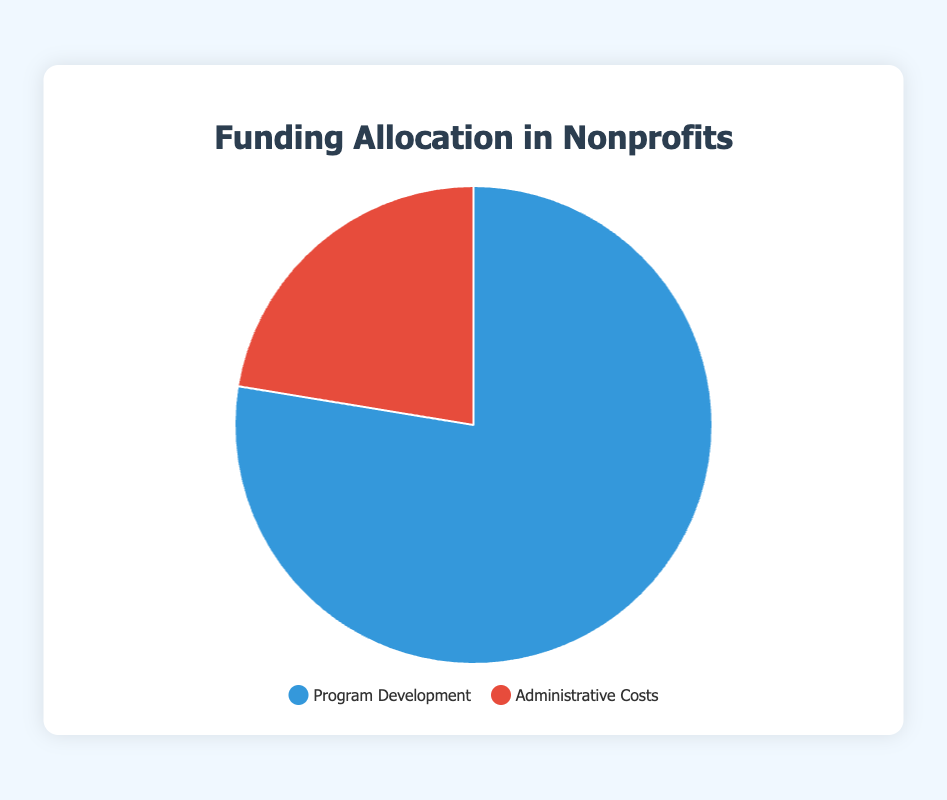What's the average allocation percentage to Program Development among all nonprofits? To calculate the average allocation percentage to Program Development, sum up all the percentages for Program Development and divide by the number of nonprofits. The sum is 75 + 85 + 80 + 70 + 78 = 388. There are 5 nonprofits, so the average is 388/5 = 77.6
Answer: 77.6% Which nonprofit allocates the most percentage to Administrative Costs? Look at the pie chart or the data and identify the nonprofit with the highest percentage allocated to Administrative Costs. Habitat for Humanity allocates 30%, which is the highest among all.
Answer: Habitat for Humanity By how much does the average Program Development allocation exceed the average Administrative Costs allocation? First, calculate the average for both Program Development (77.6%) and Administrative Costs ((25 + 15 + 20 + 30 + 22) / 5 = 22.4%). Then, find the difference: 77.6 - 22.4 = 55.2
Answer: 55.2% Which segment (Program Development or Administrative Costs) is represented by the color blue in the pie chart? Examine the legend in the pie chart where colors are assigned to different segments. Blue represents Program Development.
Answer: Program Development What is the sum of percentages allocated to Program Development and Administrative Costs for Red Cross? Add the percentages for Program Development (78%) and Administrative Costs (22%) for Red Cross: 78 + 22 = 100
Answer: 100% Which nonprofit has the lowest allocation percentage to Program Development? Identify the nonprofit with the smallest percentage allocated to Program Development. Habitat for Humanity allocates 70% to Program Development, which is the lowest.
Answer: Habitat for Humanity 